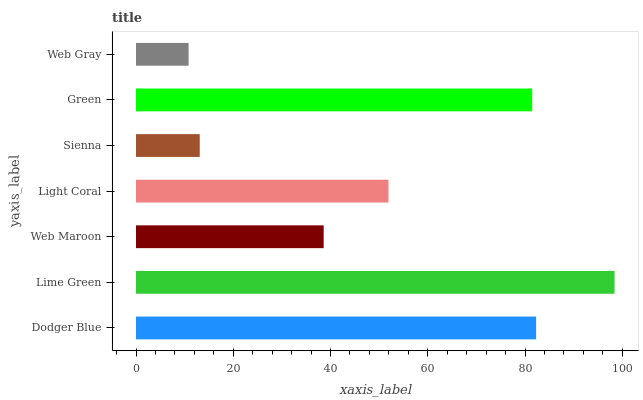Is Web Gray the minimum?
Answer yes or no. Yes. Is Lime Green the maximum?
Answer yes or no. Yes. Is Web Maroon the minimum?
Answer yes or no. No. Is Web Maroon the maximum?
Answer yes or no. No. Is Lime Green greater than Web Maroon?
Answer yes or no. Yes. Is Web Maroon less than Lime Green?
Answer yes or no. Yes. Is Web Maroon greater than Lime Green?
Answer yes or no. No. Is Lime Green less than Web Maroon?
Answer yes or no. No. Is Light Coral the high median?
Answer yes or no. Yes. Is Light Coral the low median?
Answer yes or no. Yes. Is Web Gray the high median?
Answer yes or no. No. Is Lime Green the low median?
Answer yes or no. No. 